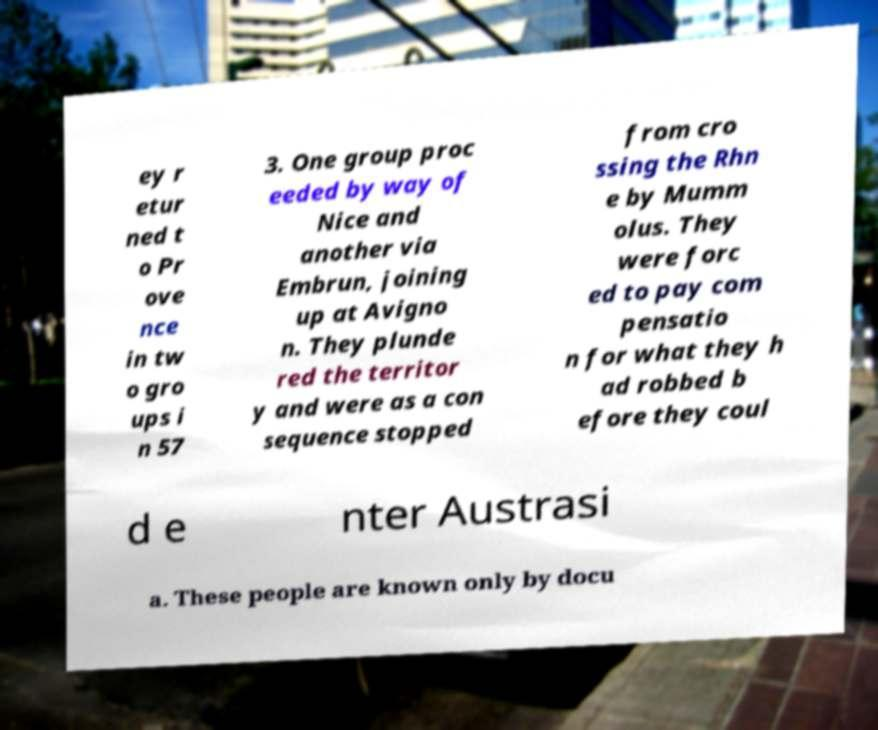Could you assist in decoding the text presented in this image and type it out clearly? ey r etur ned t o Pr ove nce in tw o gro ups i n 57 3. One group proc eeded by way of Nice and another via Embrun, joining up at Avigno n. They plunde red the territor y and were as a con sequence stopped from cro ssing the Rhn e by Mumm olus. They were forc ed to pay com pensatio n for what they h ad robbed b efore they coul d e nter Austrasi a. These people are known only by docu 